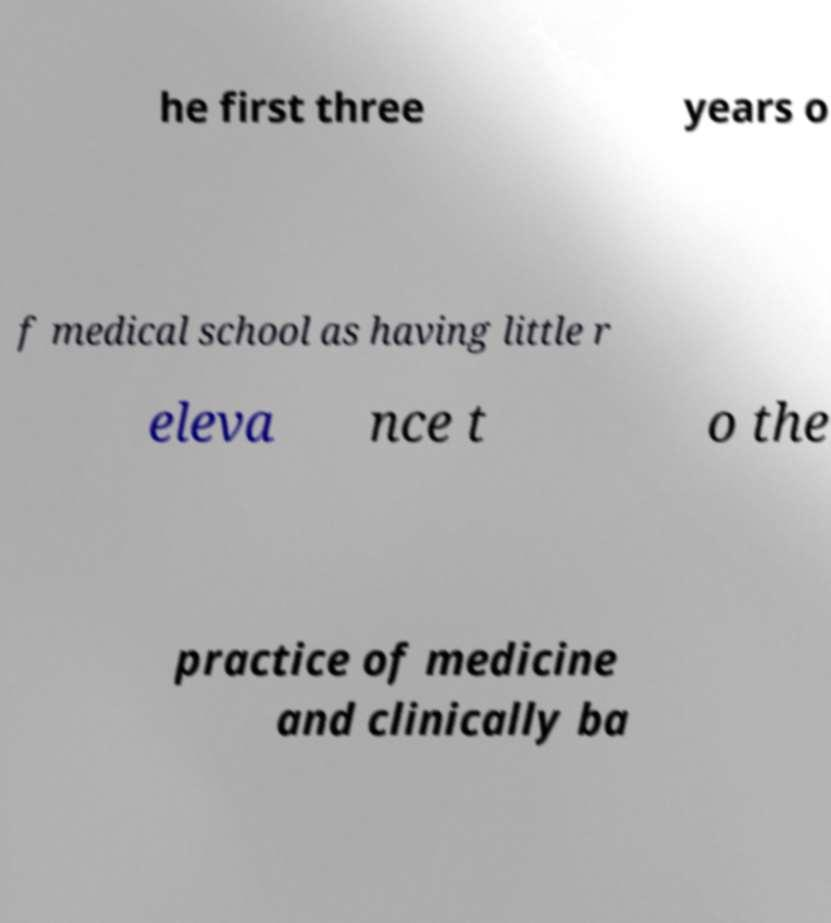I need the written content from this picture converted into text. Can you do that? he first three years o f medical school as having little r eleva nce t o the practice of medicine and clinically ba 